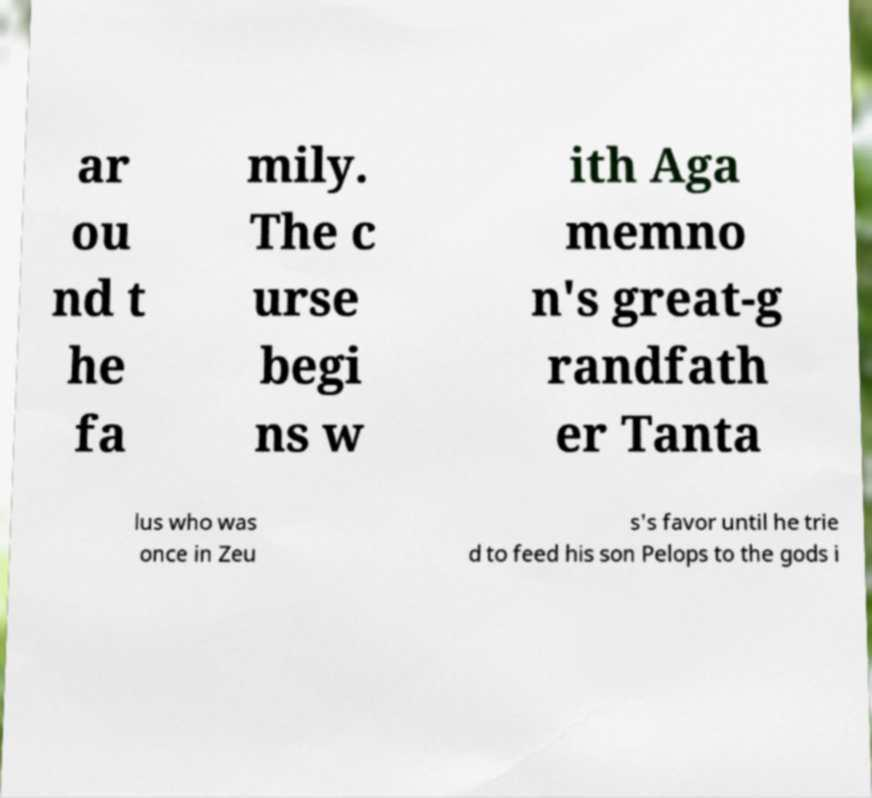Please identify and transcribe the text found in this image. ar ou nd t he fa mily. The c urse begi ns w ith Aga memno n's great-g randfath er Tanta lus who was once in Zeu s's favor until he trie d to feed his son Pelops to the gods i 